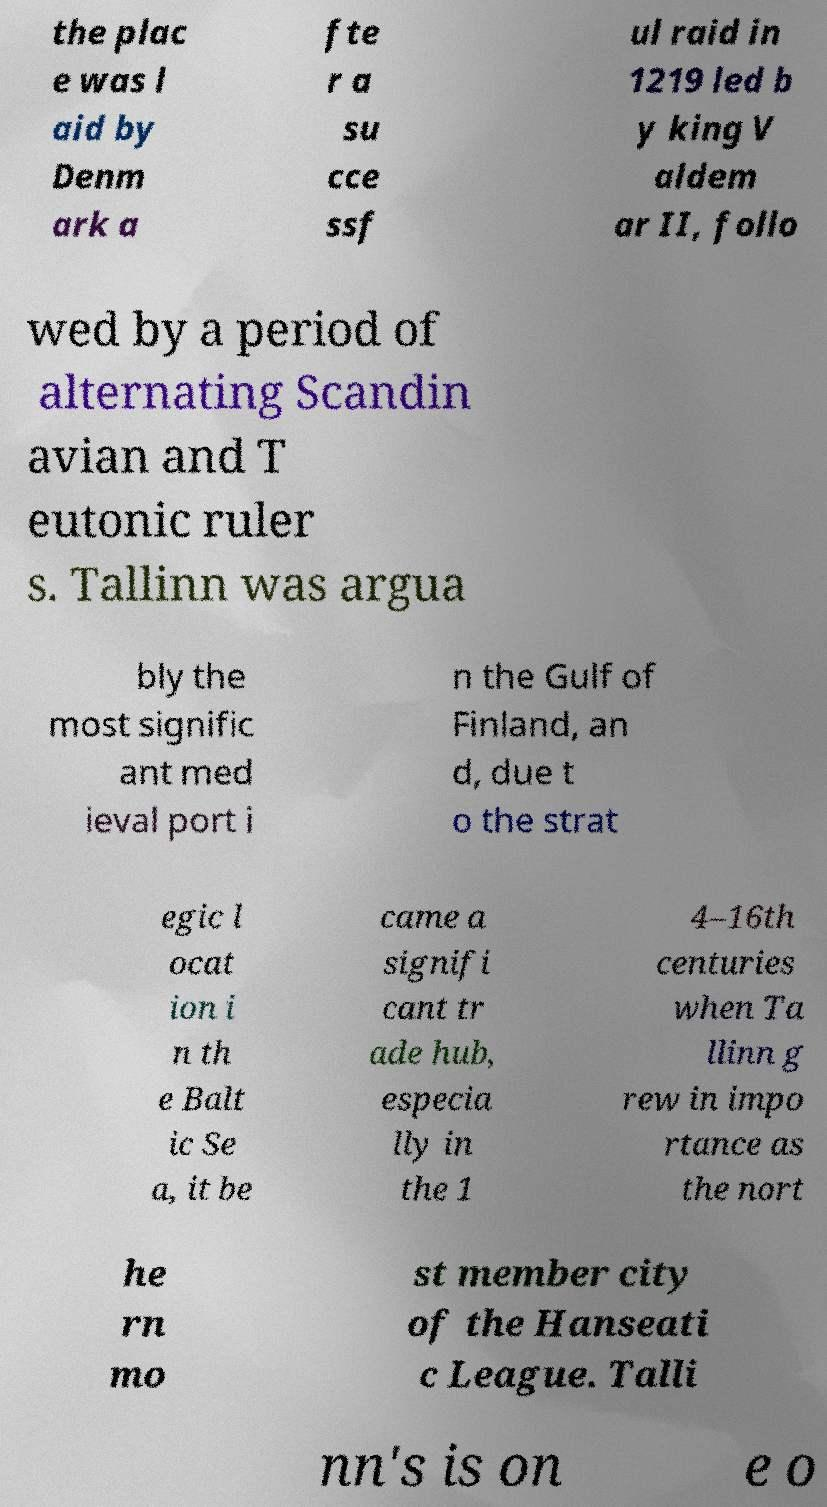There's text embedded in this image that I need extracted. Can you transcribe it verbatim? the plac e was l aid by Denm ark a fte r a su cce ssf ul raid in 1219 led b y king V aldem ar II, follo wed by a period of alternating Scandin avian and T eutonic ruler s. Tallinn was argua bly the most signific ant med ieval port i n the Gulf of Finland, an d, due t o the strat egic l ocat ion i n th e Balt ic Se a, it be came a signifi cant tr ade hub, especia lly in the 1 4–16th centuries when Ta llinn g rew in impo rtance as the nort he rn mo st member city of the Hanseati c League. Talli nn's is on e o 